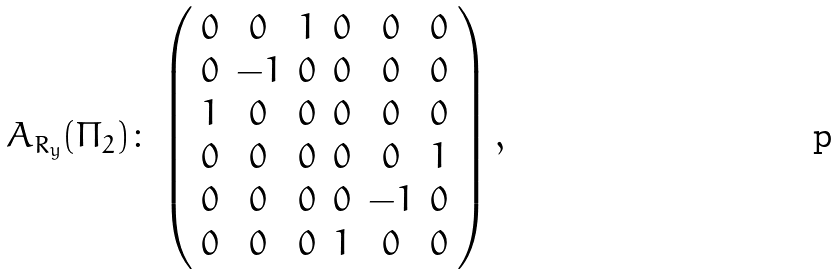Convert formula to latex. <formula><loc_0><loc_0><loc_500><loc_500>A _ { R _ { y } } ( \Pi _ { 2 } ) \colon \left ( \begin{array} { c c c c c c } 0 & 0 & 1 & 0 & 0 & 0 \\ 0 & - 1 & 0 & 0 & 0 & 0 \\ 1 & 0 & 0 & 0 & 0 & 0 \\ 0 & 0 & 0 & 0 & 0 & 1 \\ 0 & 0 & 0 & 0 & - 1 & 0 \\ 0 & 0 & 0 & 1 & 0 & 0 \end{array} \right ) ,</formula> 